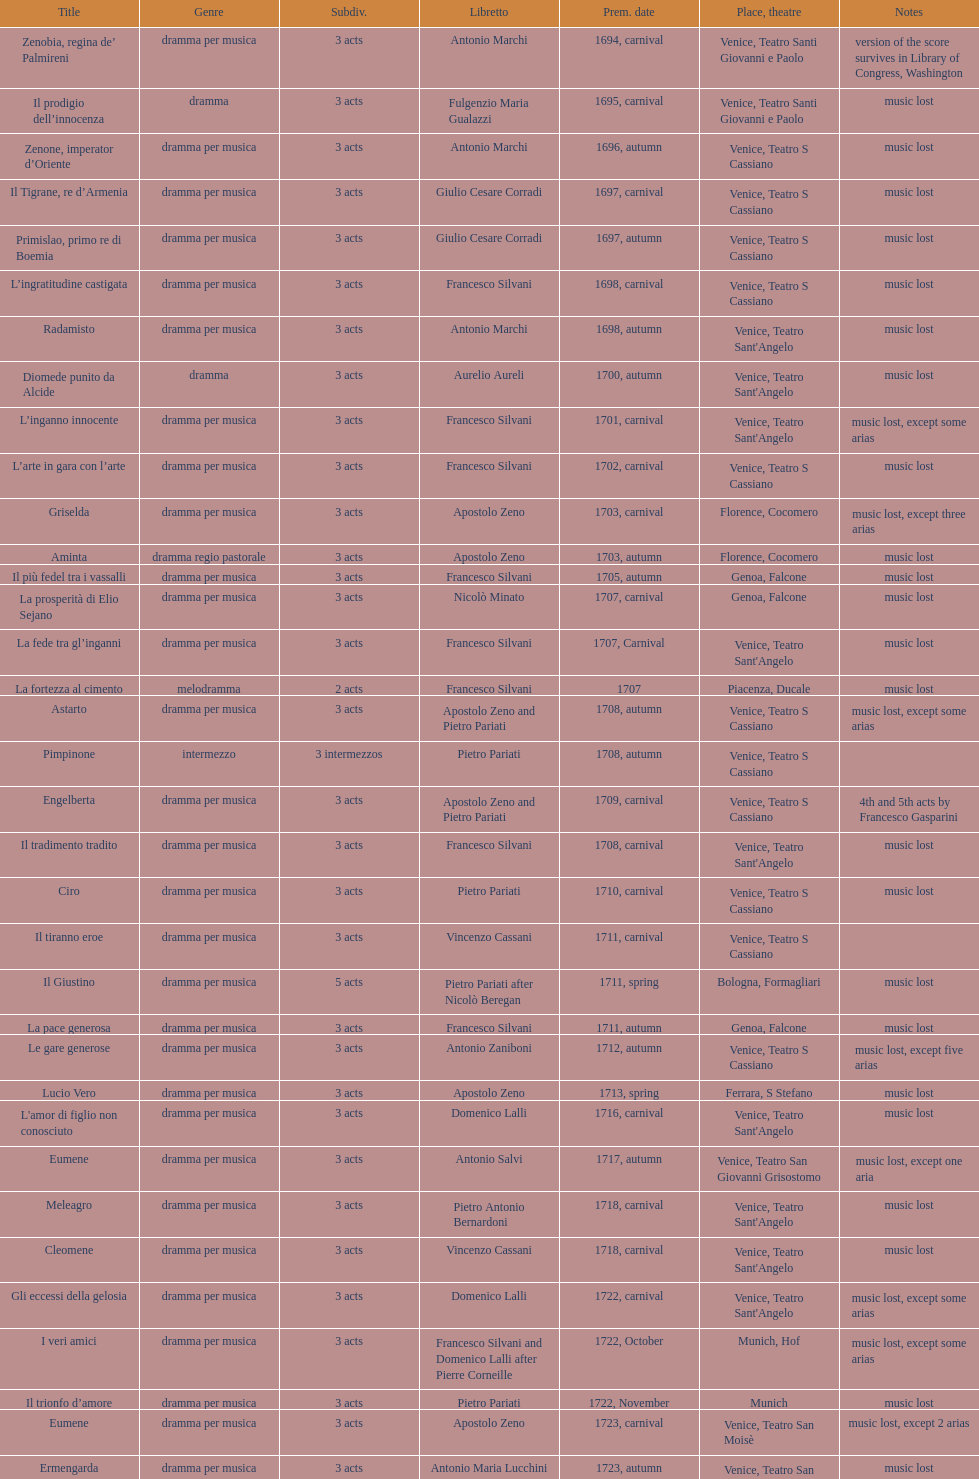L'inganno innocente premiered in 1701. what was the previous title released? Diomede punito da Alcide. 